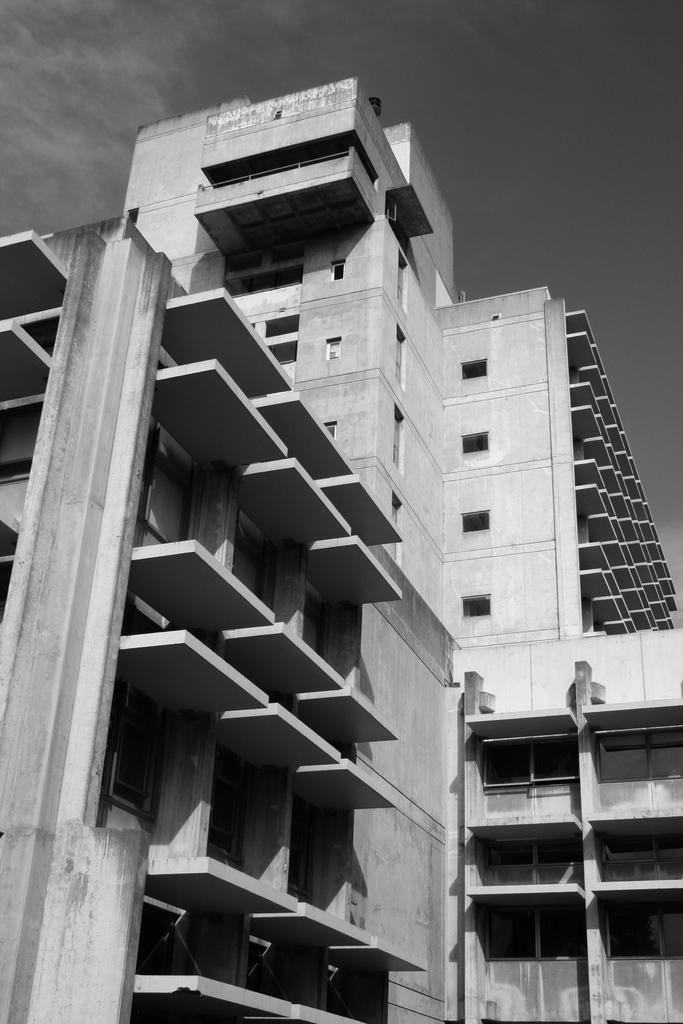What type of image is depicted in the picture? The image contains a black and white picture of a building. What can be seen in the background of the image? The sky is visible in the background of the image. How many snakes are slithering across the building in the image? There are no snakes present in the image; it features a black and white picture of a building with the sky visible in the background. 